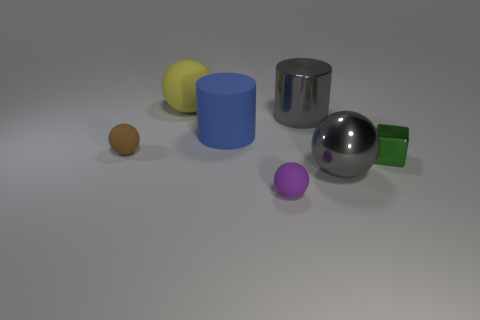Subtract all gray spheres. How many spheres are left? 3 Subtract all yellow spheres. How many spheres are left? 3 Subtract 1 balls. How many balls are left? 3 Subtract all green spheres. Subtract all cyan cubes. How many spheres are left? 4 Add 2 green things. How many objects exist? 9 Subtract all blocks. How many objects are left? 6 Subtract 0 blue spheres. How many objects are left? 7 Subtract all green matte cylinders. Subtract all small green cubes. How many objects are left? 6 Add 1 yellow rubber balls. How many yellow rubber balls are left? 2 Add 6 brown blocks. How many brown blocks exist? 6 